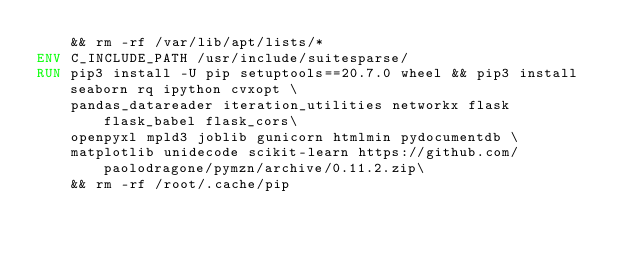<code> <loc_0><loc_0><loc_500><loc_500><_Dockerfile_>    && rm -rf /var/lib/apt/lists/*
ENV C_INCLUDE_PATH /usr/include/suitesparse/
RUN pip3 install -U pip setuptools==20.7.0 wheel && pip3 install seaborn rq ipython cvxopt \
    pandas_datareader iteration_utilities networkx flask flask_babel flask_cors\
    openpyxl mpld3 joblib gunicorn htmlmin pydocumentdb \
    matplotlib unidecode scikit-learn https://github.com/paolodragone/pymzn/archive/0.11.2.zip\
    && rm -rf /root/.cache/pip
</code> 